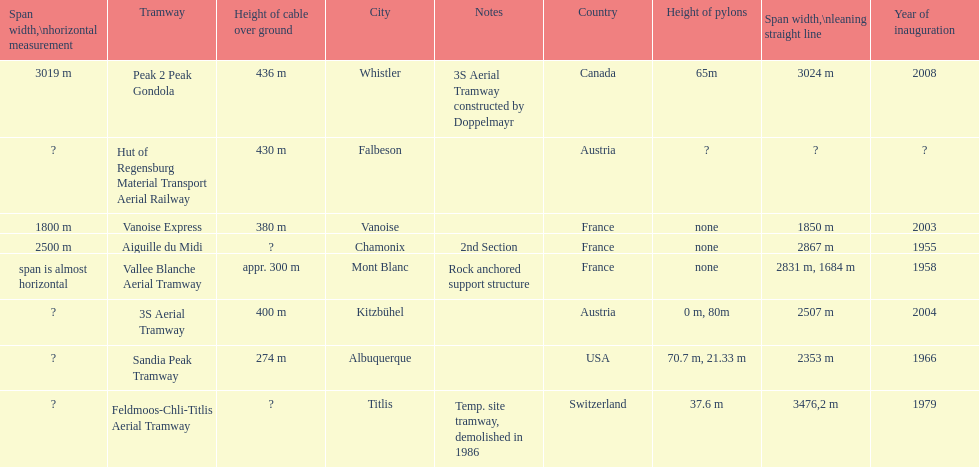How much greater is the height of cable over ground measurement for the peak 2 peak gondola when compared with that of the vanoise express? 56 m. Would you mind parsing the complete table? {'header': ['Span width,\\nhorizontal measurement', 'Tramway', 'Height of cable over ground', 'City', 'Notes', 'Country', 'Height of pylons', 'Span\xa0width,\\nleaning straight line', 'Year of inauguration'], 'rows': [['3019 m', 'Peak 2 Peak Gondola', '436 m', 'Whistler', '3S Aerial Tramway constructed by Doppelmayr', 'Canada', '65m', '3024 m', '2008'], ['?', 'Hut of Regensburg Material Transport Aerial Railway', '430 m', 'Falbeson', '', 'Austria', '?', '?', '?'], ['1800 m', 'Vanoise Express', '380 m', 'Vanoise', '', 'France', 'none', '1850 m', '2003'], ['2500 m', 'Aiguille du Midi', '?', 'Chamonix', '2nd Section', 'France', 'none', '2867 m', '1955'], ['span is almost horizontal', 'Vallee Blanche Aerial Tramway', 'appr. 300 m', 'Mont Blanc', 'Rock anchored support structure', 'France', 'none', '2831 m, 1684 m', '1958'], ['?', '3S Aerial Tramway', '400 m', 'Kitzbühel', '', 'Austria', '0 m, 80m', '2507 m', '2004'], ['?', 'Sandia Peak Tramway', '274 m', 'Albuquerque', '', 'USA', '70.7 m, 21.33 m', '2353 m', '1966'], ['?', 'Feldmoos-Chli-Titlis Aerial Tramway', '?', 'Titlis', 'Temp. site tramway, demolished in 1986', 'Switzerland', '37.6 m', '3476,2 m', '1979']]} 